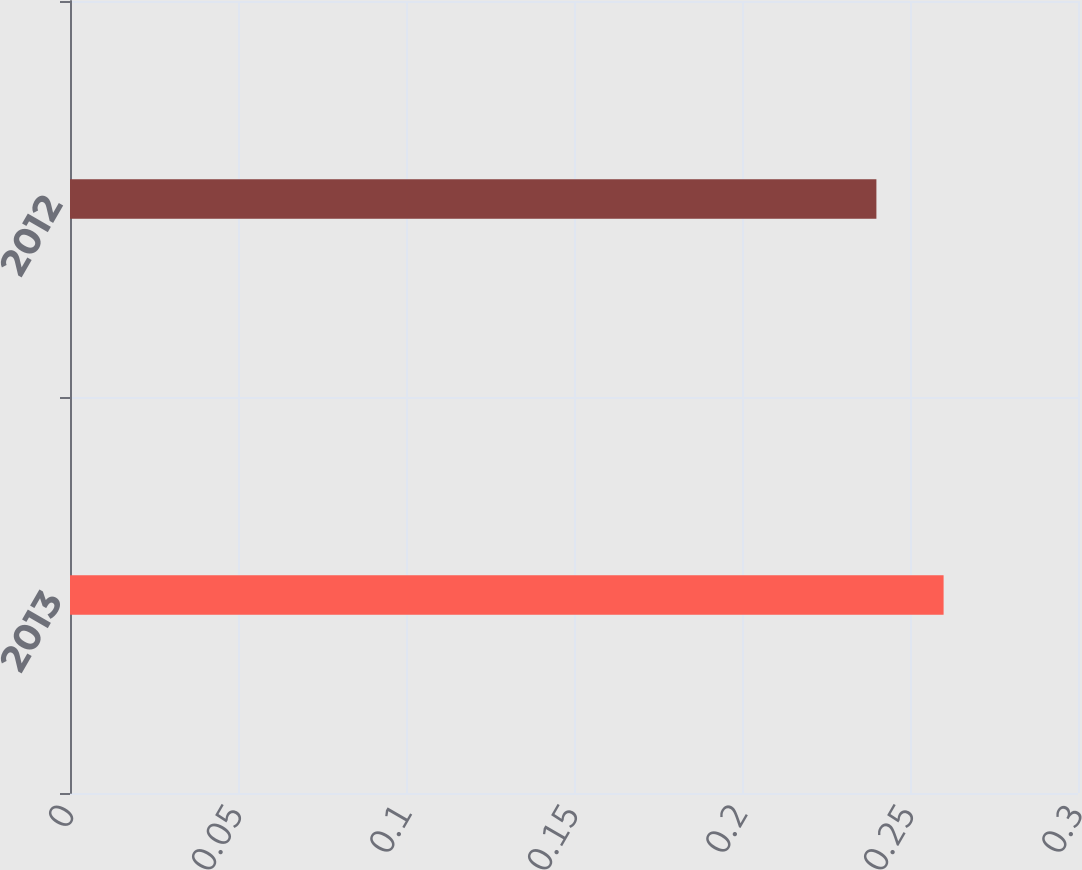Convert chart to OTSL. <chart><loc_0><loc_0><loc_500><loc_500><bar_chart><fcel>2013<fcel>2012<nl><fcel>0.26<fcel>0.24<nl></chart> 